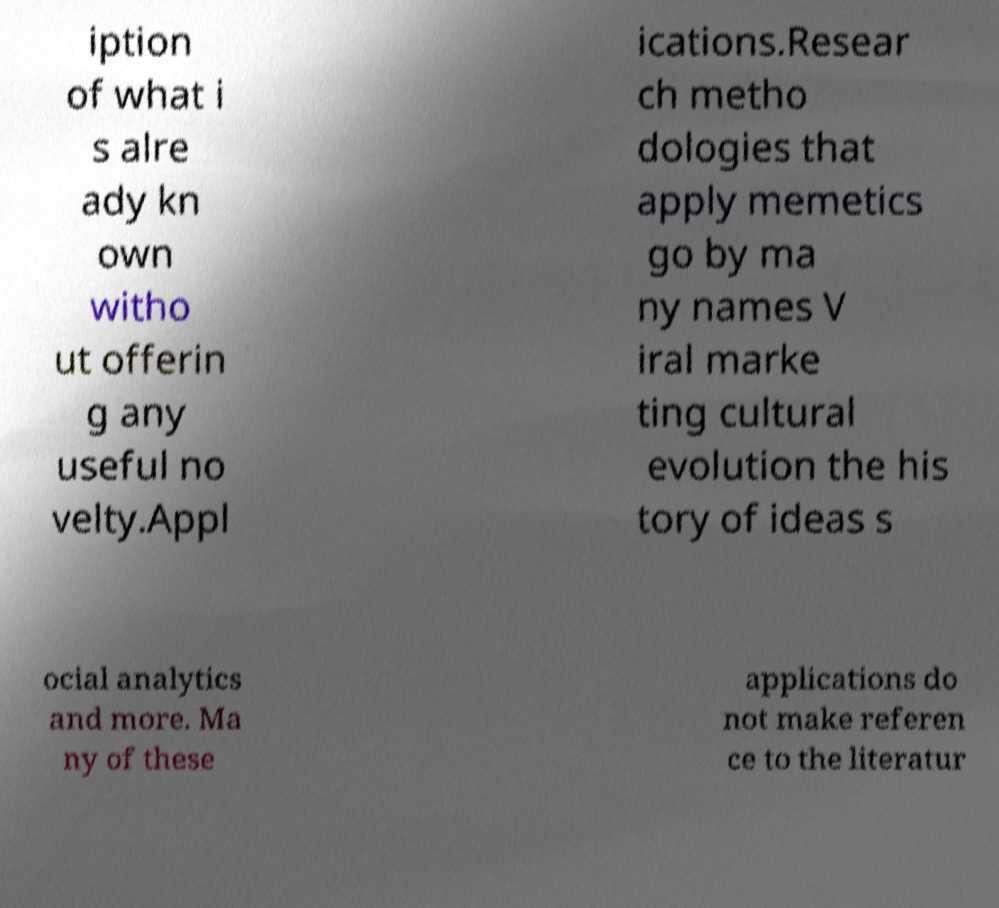There's text embedded in this image that I need extracted. Can you transcribe it verbatim? iption of what i s alre ady kn own witho ut offerin g any useful no velty.Appl ications.Resear ch metho dologies that apply memetics go by ma ny names V iral marke ting cultural evolution the his tory of ideas s ocial analytics and more. Ma ny of these applications do not make referen ce to the literatur 